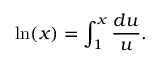Convert formula to latex. <formula><loc_0><loc_0><loc_500><loc_500>\ln ( x ) = \int _ { 1 } ^ { x } { \frac { d u } { u } } .</formula> 